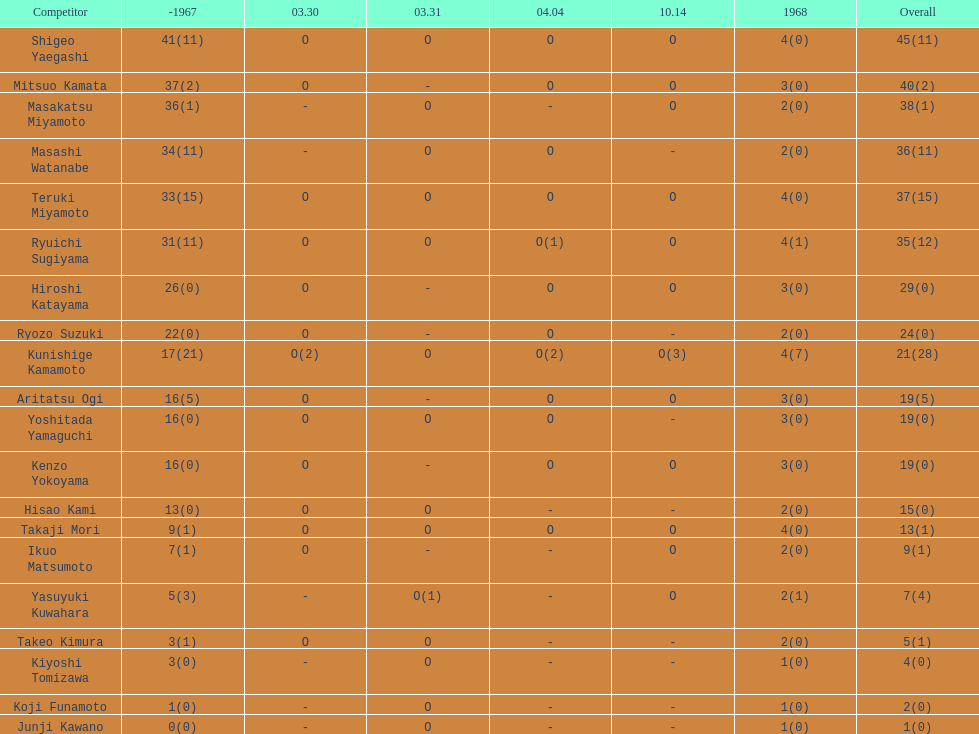I'm looking to parse the entire table for insights. Could you assist me with that? {'header': ['Competitor', '-1967', '03.30', '03.31', '04.04', '10.14', '1968', 'Overall'], 'rows': [['Shigeo Yaegashi', '41(11)', 'O', 'O', 'O', 'O', '4(0)', '45(11)'], ['Mitsuo Kamata', '37(2)', 'O', '-', 'O', 'O', '3(0)', '40(2)'], ['Masakatsu Miyamoto', '36(1)', '-', 'O', '-', 'O', '2(0)', '38(1)'], ['Masashi Watanabe', '34(11)', '-', 'O', 'O', '-', '2(0)', '36(11)'], ['Teruki Miyamoto', '33(15)', 'O', 'O', 'O', 'O', '4(0)', '37(15)'], ['Ryuichi Sugiyama', '31(11)', 'O', 'O', 'O(1)', 'O', '4(1)', '35(12)'], ['Hiroshi Katayama', '26(0)', 'O', '-', 'O', 'O', '3(0)', '29(0)'], ['Ryozo Suzuki', '22(0)', 'O', '-', 'O', '-', '2(0)', '24(0)'], ['Kunishige Kamamoto', '17(21)', 'O(2)', 'O', 'O(2)', 'O(3)', '4(7)', '21(28)'], ['Aritatsu Ogi', '16(5)', 'O', '-', 'O', 'O', '3(0)', '19(5)'], ['Yoshitada Yamaguchi', '16(0)', 'O', 'O', 'O', '-', '3(0)', '19(0)'], ['Kenzo Yokoyama', '16(0)', 'O', '-', 'O', 'O', '3(0)', '19(0)'], ['Hisao Kami', '13(0)', 'O', 'O', '-', '-', '2(0)', '15(0)'], ['Takaji Mori', '9(1)', 'O', 'O', 'O', 'O', '4(0)', '13(1)'], ['Ikuo Matsumoto', '7(1)', 'O', '-', '-', 'O', '2(0)', '9(1)'], ['Yasuyuki Kuwahara', '5(3)', '-', 'O(1)', '-', 'O', '2(1)', '7(4)'], ['Takeo Kimura', '3(1)', 'O', 'O', '-', '-', '2(0)', '5(1)'], ['Kiyoshi Tomizawa', '3(0)', '-', 'O', '-', '-', '1(0)', '4(0)'], ['Koji Funamoto', '1(0)', '-', 'O', '-', '-', '1(0)', '2(0)'], ['Junji Kawano', '0(0)', '-', 'O', '-', '-', '1(0)', '1(0)']]} Which player had a higher score, takaji mori or junji kawano? Takaji Mori. 